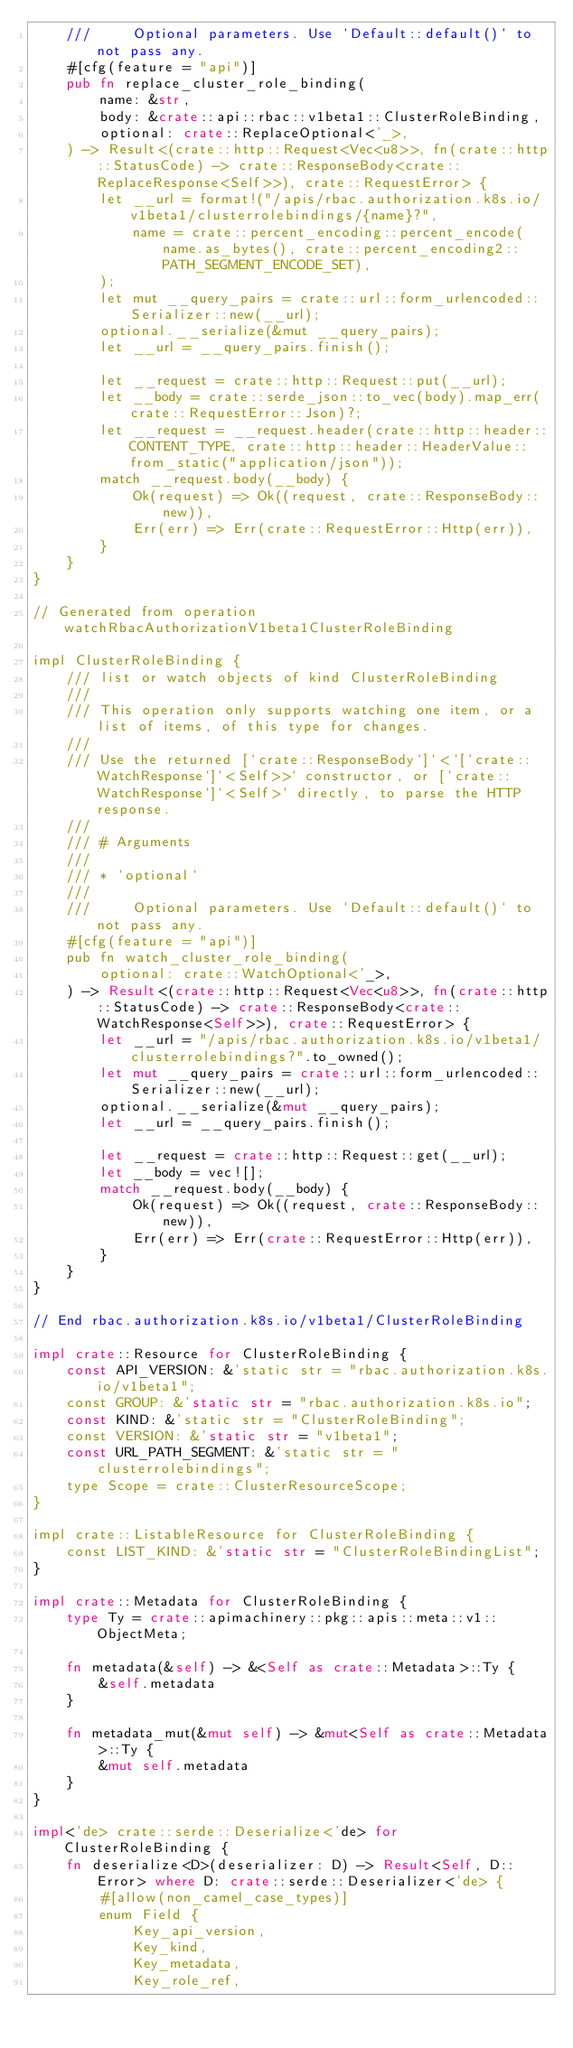Convert code to text. <code><loc_0><loc_0><loc_500><loc_500><_Rust_>    ///     Optional parameters. Use `Default::default()` to not pass any.
    #[cfg(feature = "api")]
    pub fn replace_cluster_role_binding(
        name: &str,
        body: &crate::api::rbac::v1beta1::ClusterRoleBinding,
        optional: crate::ReplaceOptional<'_>,
    ) -> Result<(crate::http::Request<Vec<u8>>, fn(crate::http::StatusCode) -> crate::ResponseBody<crate::ReplaceResponse<Self>>), crate::RequestError> {
        let __url = format!("/apis/rbac.authorization.k8s.io/v1beta1/clusterrolebindings/{name}?",
            name = crate::percent_encoding::percent_encode(name.as_bytes(), crate::percent_encoding2::PATH_SEGMENT_ENCODE_SET),
        );
        let mut __query_pairs = crate::url::form_urlencoded::Serializer::new(__url);
        optional.__serialize(&mut __query_pairs);
        let __url = __query_pairs.finish();

        let __request = crate::http::Request::put(__url);
        let __body = crate::serde_json::to_vec(body).map_err(crate::RequestError::Json)?;
        let __request = __request.header(crate::http::header::CONTENT_TYPE, crate::http::header::HeaderValue::from_static("application/json"));
        match __request.body(__body) {
            Ok(request) => Ok((request, crate::ResponseBody::new)),
            Err(err) => Err(crate::RequestError::Http(err)),
        }
    }
}

// Generated from operation watchRbacAuthorizationV1beta1ClusterRoleBinding

impl ClusterRoleBinding {
    /// list or watch objects of kind ClusterRoleBinding
    ///
    /// This operation only supports watching one item, or a list of items, of this type for changes.
    ///
    /// Use the returned [`crate::ResponseBody`]`<`[`crate::WatchResponse`]`<Self>>` constructor, or [`crate::WatchResponse`]`<Self>` directly, to parse the HTTP response.
    ///
    /// # Arguments
    ///
    /// * `optional`
    ///
    ///     Optional parameters. Use `Default::default()` to not pass any.
    #[cfg(feature = "api")]
    pub fn watch_cluster_role_binding(
        optional: crate::WatchOptional<'_>,
    ) -> Result<(crate::http::Request<Vec<u8>>, fn(crate::http::StatusCode) -> crate::ResponseBody<crate::WatchResponse<Self>>), crate::RequestError> {
        let __url = "/apis/rbac.authorization.k8s.io/v1beta1/clusterrolebindings?".to_owned();
        let mut __query_pairs = crate::url::form_urlencoded::Serializer::new(__url);
        optional.__serialize(&mut __query_pairs);
        let __url = __query_pairs.finish();

        let __request = crate::http::Request::get(__url);
        let __body = vec![];
        match __request.body(__body) {
            Ok(request) => Ok((request, crate::ResponseBody::new)),
            Err(err) => Err(crate::RequestError::Http(err)),
        }
    }
}

// End rbac.authorization.k8s.io/v1beta1/ClusterRoleBinding

impl crate::Resource for ClusterRoleBinding {
    const API_VERSION: &'static str = "rbac.authorization.k8s.io/v1beta1";
    const GROUP: &'static str = "rbac.authorization.k8s.io";
    const KIND: &'static str = "ClusterRoleBinding";
    const VERSION: &'static str = "v1beta1";
    const URL_PATH_SEGMENT: &'static str = "clusterrolebindings";
    type Scope = crate::ClusterResourceScope;
}

impl crate::ListableResource for ClusterRoleBinding {
    const LIST_KIND: &'static str = "ClusterRoleBindingList";
}

impl crate::Metadata for ClusterRoleBinding {
    type Ty = crate::apimachinery::pkg::apis::meta::v1::ObjectMeta;

    fn metadata(&self) -> &<Self as crate::Metadata>::Ty {
        &self.metadata
    }

    fn metadata_mut(&mut self) -> &mut<Self as crate::Metadata>::Ty {
        &mut self.metadata
    }
}

impl<'de> crate::serde::Deserialize<'de> for ClusterRoleBinding {
    fn deserialize<D>(deserializer: D) -> Result<Self, D::Error> where D: crate::serde::Deserializer<'de> {
        #[allow(non_camel_case_types)]
        enum Field {
            Key_api_version,
            Key_kind,
            Key_metadata,
            Key_role_ref,</code> 